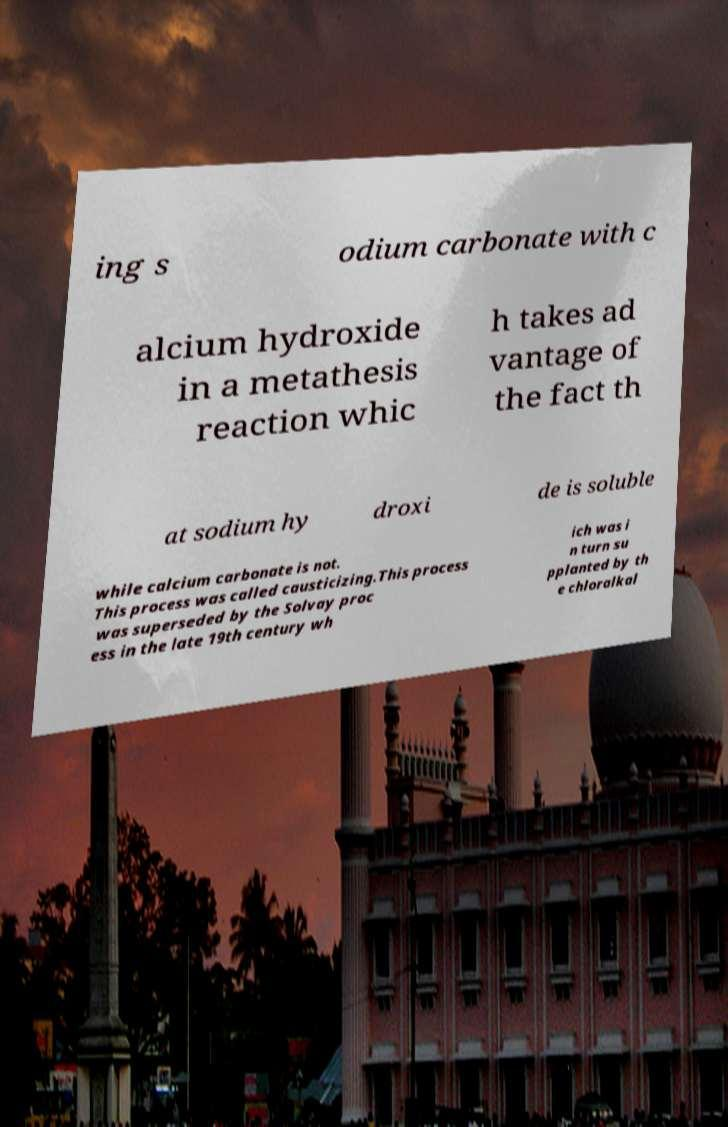Can you read and provide the text displayed in the image?This photo seems to have some interesting text. Can you extract and type it out for me? ing s odium carbonate with c alcium hydroxide in a metathesis reaction whic h takes ad vantage of the fact th at sodium hy droxi de is soluble while calcium carbonate is not. This process was called causticizing.This process was superseded by the Solvay proc ess in the late 19th century wh ich was i n turn su pplanted by th e chloralkal 